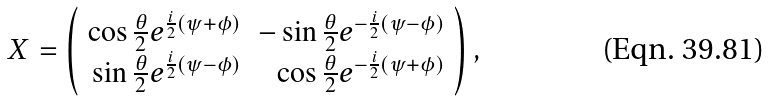Convert formula to latex. <formula><loc_0><loc_0><loc_500><loc_500>X = \left ( \begin{array} { r r } \cos \frac { \theta } { 2 } e ^ { \frac { i } { 2 } ( \psi + \phi ) } & - \sin \frac { \theta } { 2 } e ^ { - \frac { i } { 2 } ( \psi - \phi ) } \\ \sin \frac { \theta } { 2 } e ^ { \frac { i } { 2 } ( \psi - \phi ) } & \cos \frac { \theta } { 2 } e ^ { - \frac { i } { 2 } ( \psi + \phi ) } \end{array} \right ) ,</formula> 